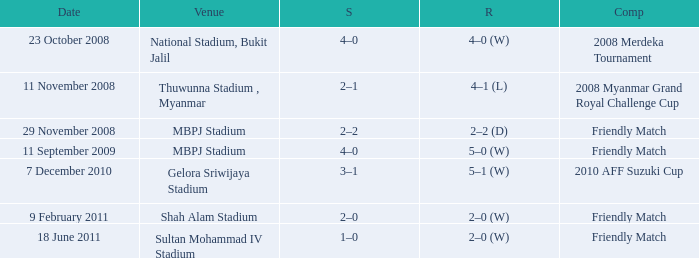What was the tally at gelora sriwijaya stadium? 3–1. 